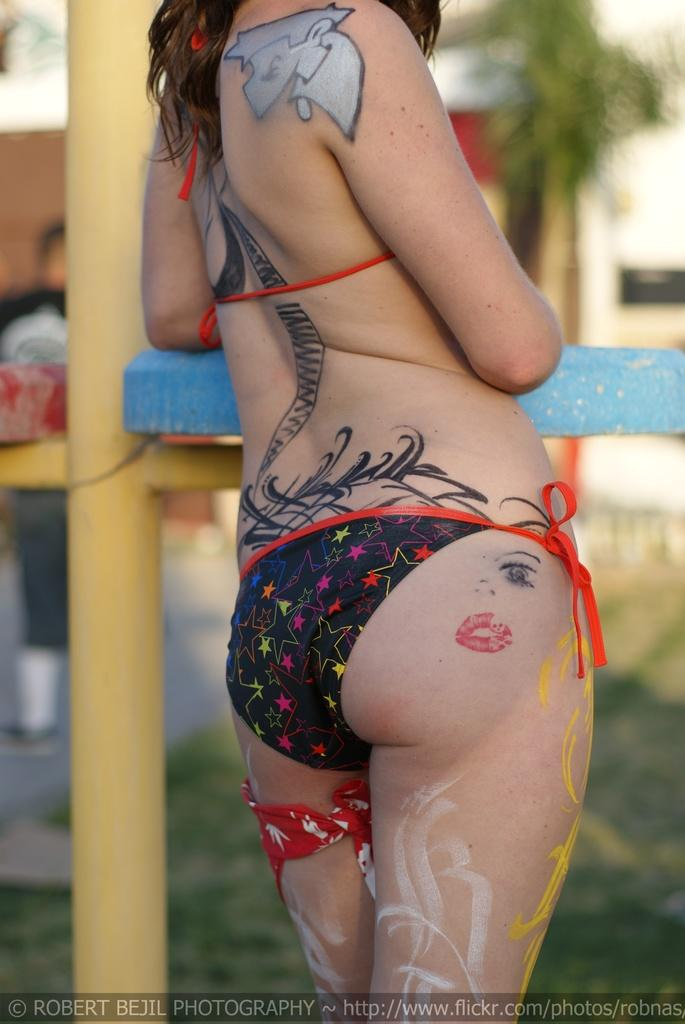What is the main subject of the image? There is a person standing in the image. What else can be seen in the image besides the person? There are paintings and a tattoo visible in the image. Can you describe the woman's attire in the image? The woman is wearing a red-colored kerchief tied around her thigh. How many trees are visible in the image? There are no trees visible in the image. What type of pump is being used by the woman in the image? There is no pump present in the image. 